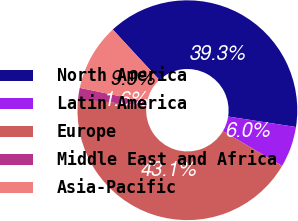<chart> <loc_0><loc_0><loc_500><loc_500><pie_chart><fcel>North America<fcel>Latin America<fcel>Europe<fcel>Middle East and Africa<fcel>Asia-Pacific<nl><fcel>39.32%<fcel>6.02%<fcel>43.15%<fcel>1.65%<fcel>9.86%<nl></chart> 